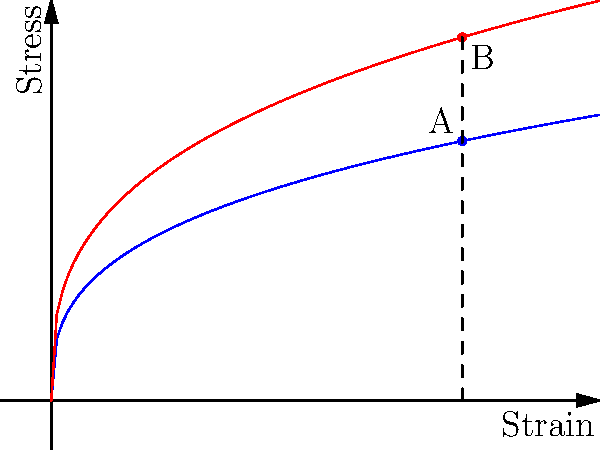Analyze the stress-strain curves for healthy and pest-attacked plant stems. At a strain of 6, what is the percentage increase in stress for the pest-attacked stem compared to the healthy stem? To solve this problem, we'll follow these steps:

1. Identify the stress values for both stems at a strain of 6:
   - Point A: Healthy stem
   - Point B: Pest-attacked stem

2. Calculate the stress values:
   - Healthy stem: $f(x) = 0.5x^{1/3}$
     $f(6) = 0.5 \cdot 6^{1/3} \approx 0.9177$
   - Pest-attacked stem: $g(x) = 0.7x^{1/3}$
     $g(6) = 0.7 \cdot 6^{1/3} \approx 1.2848$

3. Calculate the difference in stress:
   $\text{Difference} = 1.2848 - 0.9177 = 0.3671$

4. Calculate the percentage increase:
   $\text{Percentage increase} = \frac{\text{Difference}}{\text{Healthy stem stress}} \times 100\%$
   $= \frac{0.3671}{0.9177} \times 100\% \approx 40\%$

Therefore, the pest-attacked stem experiences approximately 40% more stress than the healthy stem at a strain of 6.
Answer: 40% 